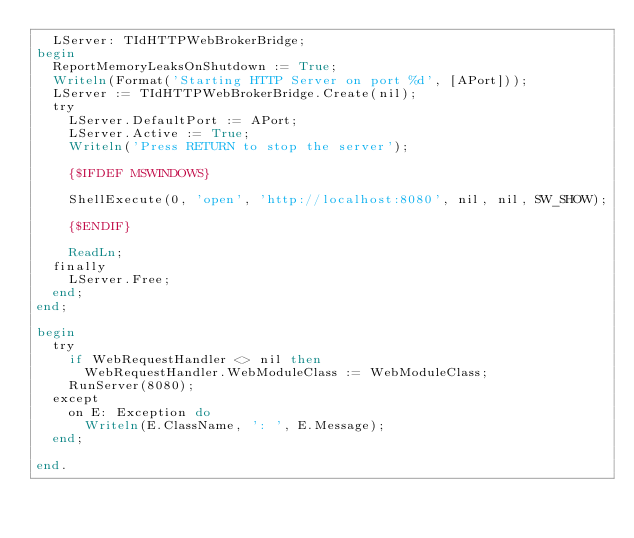Convert code to text. <code><loc_0><loc_0><loc_500><loc_500><_Pascal_>  LServer: TIdHTTPWebBrokerBridge;
begin
  ReportMemoryLeaksOnShutdown := True;
  Writeln(Format('Starting HTTP Server on port %d', [APort]));
  LServer := TIdHTTPWebBrokerBridge.Create(nil);
  try
    LServer.DefaultPort := APort;
    LServer.Active := True;
    Writeln('Press RETURN to stop the server');

    {$IFDEF MSWINDOWS}

    ShellExecute(0, 'open', 'http://localhost:8080', nil, nil, SW_SHOW);

    {$ENDIF}

    ReadLn;
  finally
    LServer.Free;
  end;
end;

begin
  try
    if WebRequestHandler <> nil then
      WebRequestHandler.WebModuleClass := WebModuleClass;
    RunServer(8080);
  except
    on E: Exception do
      Writeln(E.ClassName, ': ', E.Message);
  end;

end.
</code> 